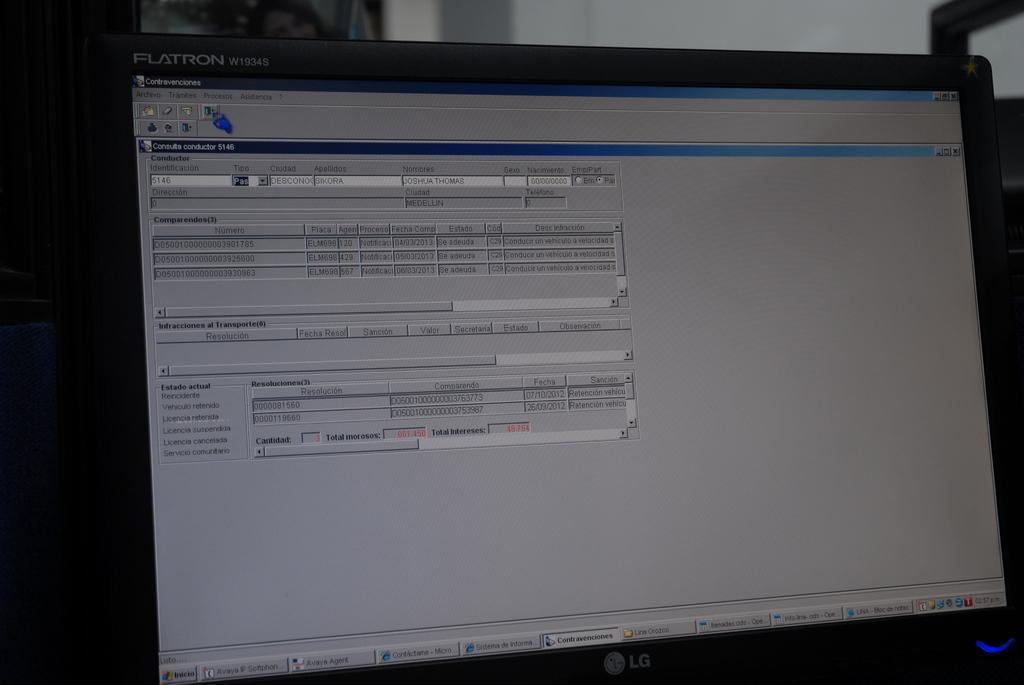Describe this image in one or two sentences. In this image, we can see a computer. Top of the image, there is a wall. 